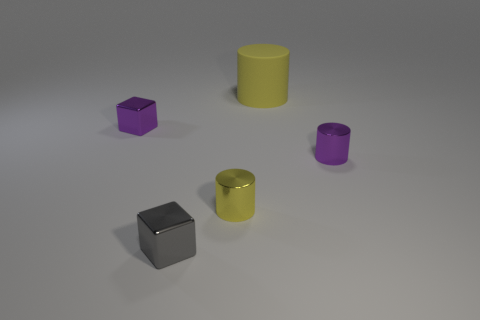What is the size of the other cube that is made of the same material as the gray block?
Your answer should be compact. Small. There is a tiny purple shiny cylinder; what number of gray objects are to the left of it?
Make the answer very short. 1. Are there the same number of large yellow cylinders in front of the yellow matte cylinder and gray metallic cubes behind the yellow metal cylinder?
Give a very brief answer. Yes. What is the size of the yellow shiny thing that is the same shape as the yellow matte thing?
Ensure brevity in your answer.  Small. There is a tiny metal thing in front of the yellow metal cylinder; what shape is it?
Your answer should be compact. Cube. Does the yellow thing in front of the big rubber object have the same material as the small purple object left of the yellow metal cylinder?
Provide a succinct answer. Yes. The tiny gray metallic object is what shape?
Ensure brevity in your answer.  Cube. Is the number of small yellow metal objects on the left side of the gray object the same as the number of large yellow balls?
Provide a short and direct response. Yes. What size is the metal thing that is the same color as the matte cylinder?
Your response must be concise. Small. Is there a blue sphere that has the same material as the purple cylinder?
Your response must be concise. No. 